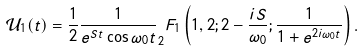<formula> <loc_0><loc_0><loc_500><loc_500>\mathcal { U } _ { 1 } ( t ) = \frac { 1 } { 2 } \frac { 1 } { e ^ { S t } \cos \omega _ { 0 } t } _ { 2 } F _ { 1 } \left ( 1 , 2 ; 2 - \frac { i S } { \omega _ { 0 } } ; \frac { 1 } { 1 + e ^ { 2 i \omega _ { 0 } t } } \right ) .</formula> 